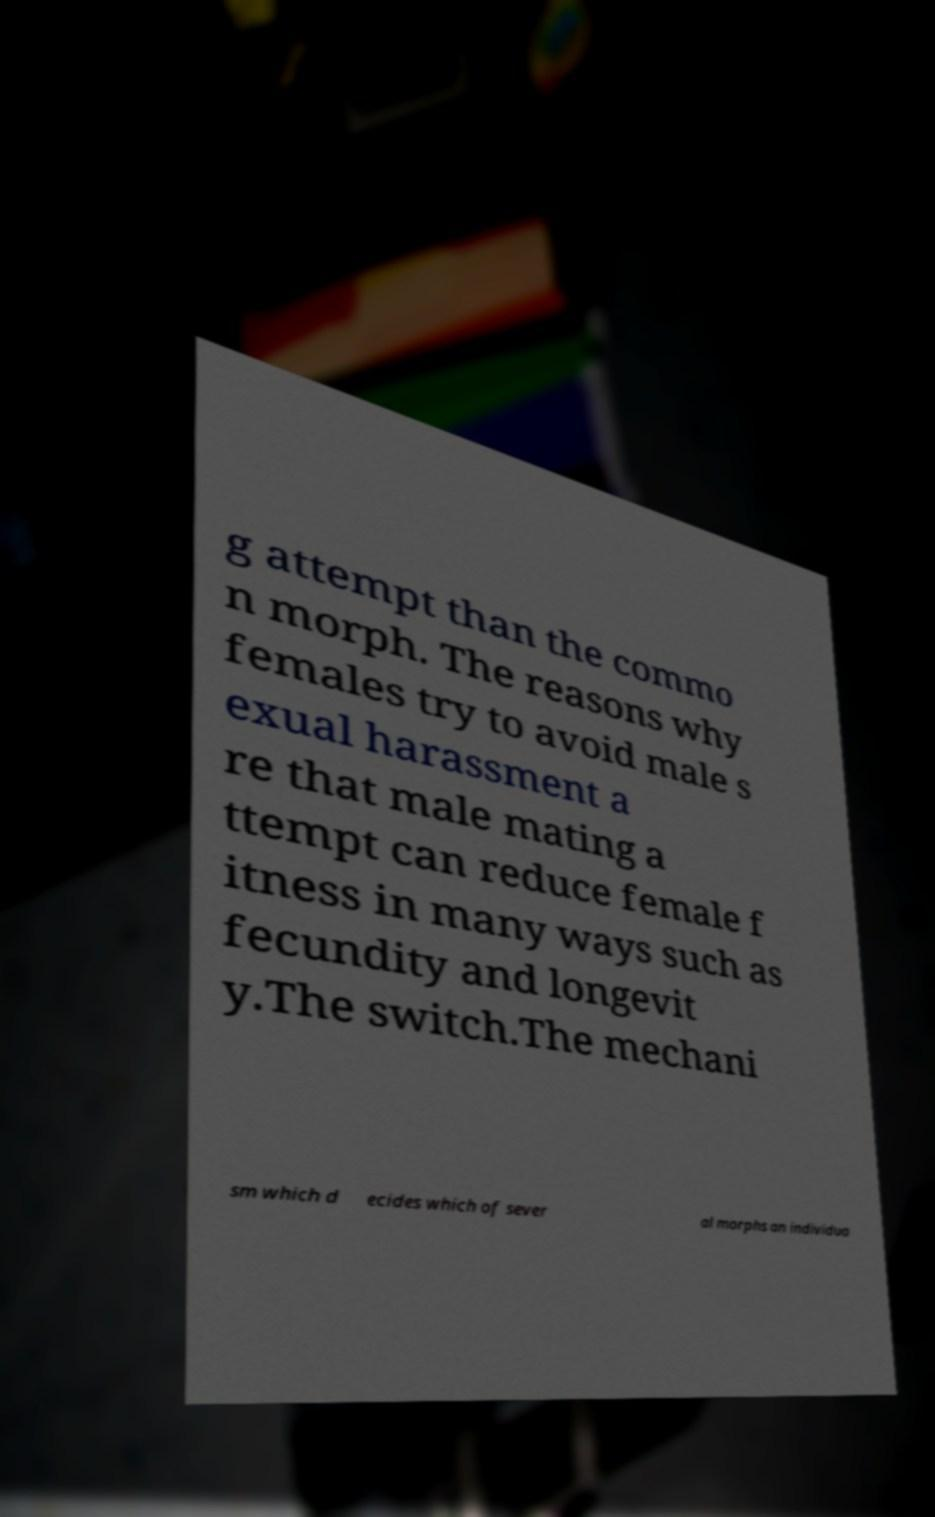Can you accurately transcribe the text from the provided image for me? g attempt than the commo n morph. The reasons why females try to avoid male s exual harassment a re that male mating a ttempt can reduce female f itness in many ways such as fecundity and longevit y.The switch.The mechani sm which d ecides which of sever al morphs an individua 